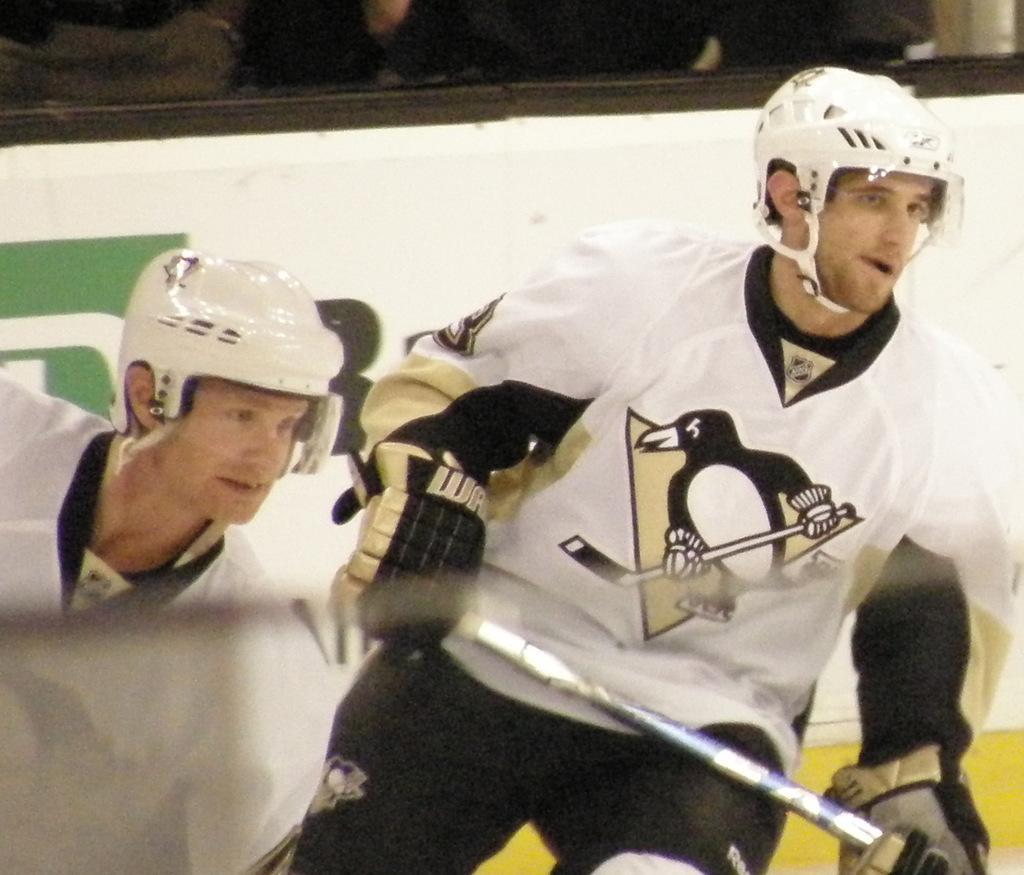In one or two sentences, can you explain what this image depicts? In this image there are two men. They are wearing gloves, jackets and helmets. The man to the right is holding a stick in his hand. Behind them there is a board. There is text on the board. 